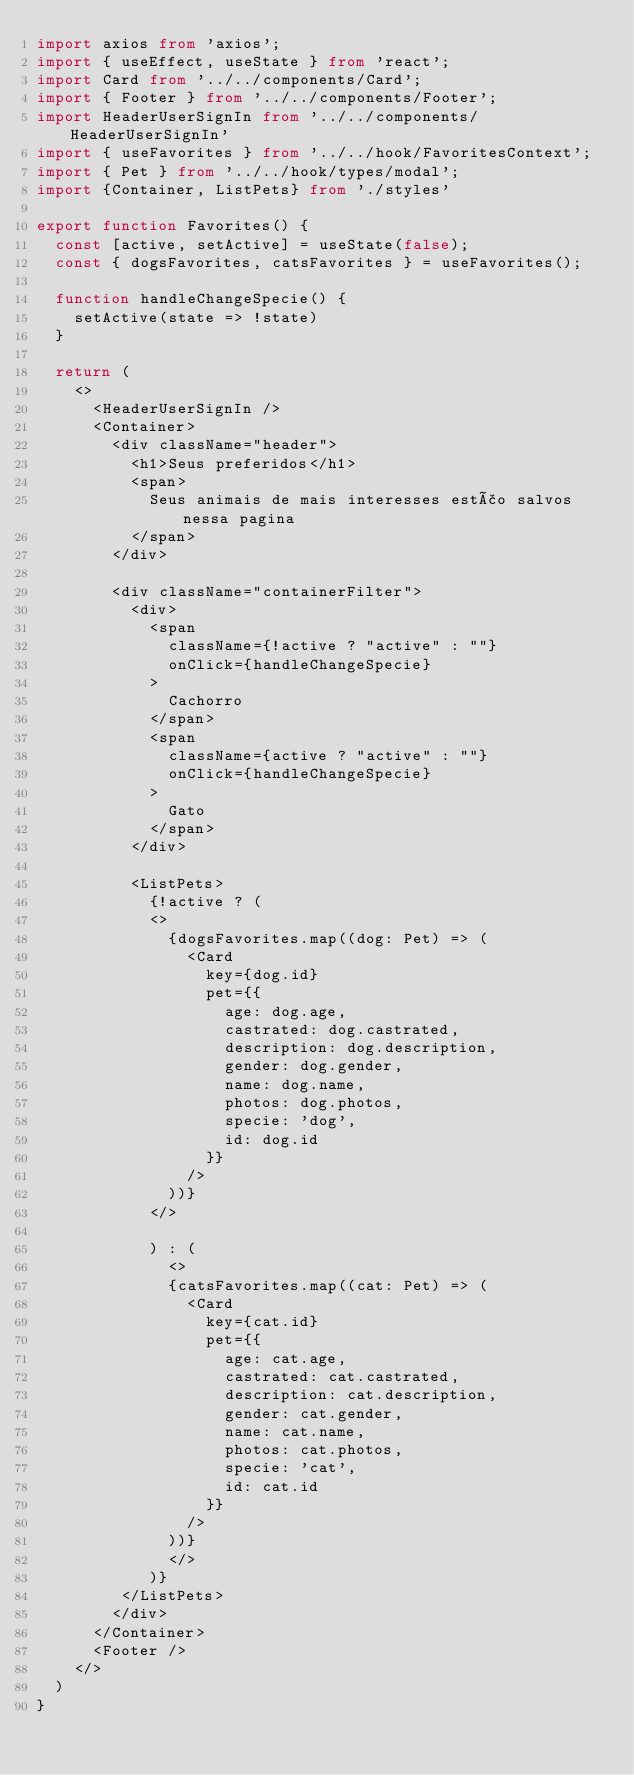Convert code to text. <code><loc_0><loc_0><loc_500><loc_500><_TypeScript_>import axios from 'axios';
import { useEffect, useState } from 'react';
import Card from '../../components/Card';
import { Footer } from '../../components/Footer';
import HeaderUserSignIn from '../../components/HeaderUserSignIn'
import { useFavorites } from '../../hook/FavoritesContext';
import { Pet } from '../../hook/types/modal';
import {Container, ListPets} from './styles'

export function Favorites() {
  const [active, setActive] = useState(false);
  const { dogsFavorites, catsFavorites } = useFavorites();

  function handleChangeSpecie() {
    setActive(state => !state)
  }

  return (
    <>
      <HeaderUserSignIn />
      <Container>
        <div className="header">
          <h1>Seus preferidos</h1>
          <span>
            Seus animais de mais interesses estão salvos nessa pagina
          </span>
        </div> 

        <div className="containerFilter">
          <div>
            <span
              className={!active ? "active" : ""}
              onClick={handleChangeSpecie}
            >
              Cachorro
            </span>
            <span
              className={active ? "active" : ""}
              onClick={handleChangeSpecie}
            >
              Gato
            </span>
          </div>

          <ListPets>
            {!active ? (
            <>
              {dogsFavorites.map((dog: Pet) => (
                <Card
                  key={dog.id}
                  pet={{
                    age: dog.age,
                    castrated: dog.castrated,
                    description: dog.description,
                    gender: dog.gender,
                    name: dog.name,
                    photos: dog.photos,
                    specie: 'dog',
                    id: dog.id
                  }}
                />
              ))}
            </>
 
            ) : (
              <>
              {catsFavorites.map((cat: Pet) => (
                <Card
                  key={cat.id}
                  pet={{
                    age: cat.age,
                    castrated: cat.castrated,
                    description: cat.description,
                    gender: cat.gender,
                    name: cat.name,
                    photos: cat.photos,
                    specie: 'cat',
                    id: cat.id
                  }}
                />
              ))}
              </>
            )}
         </ListPets>
        </div>
      </Container>
      <Footer />
    </>
  )
}

</code> 